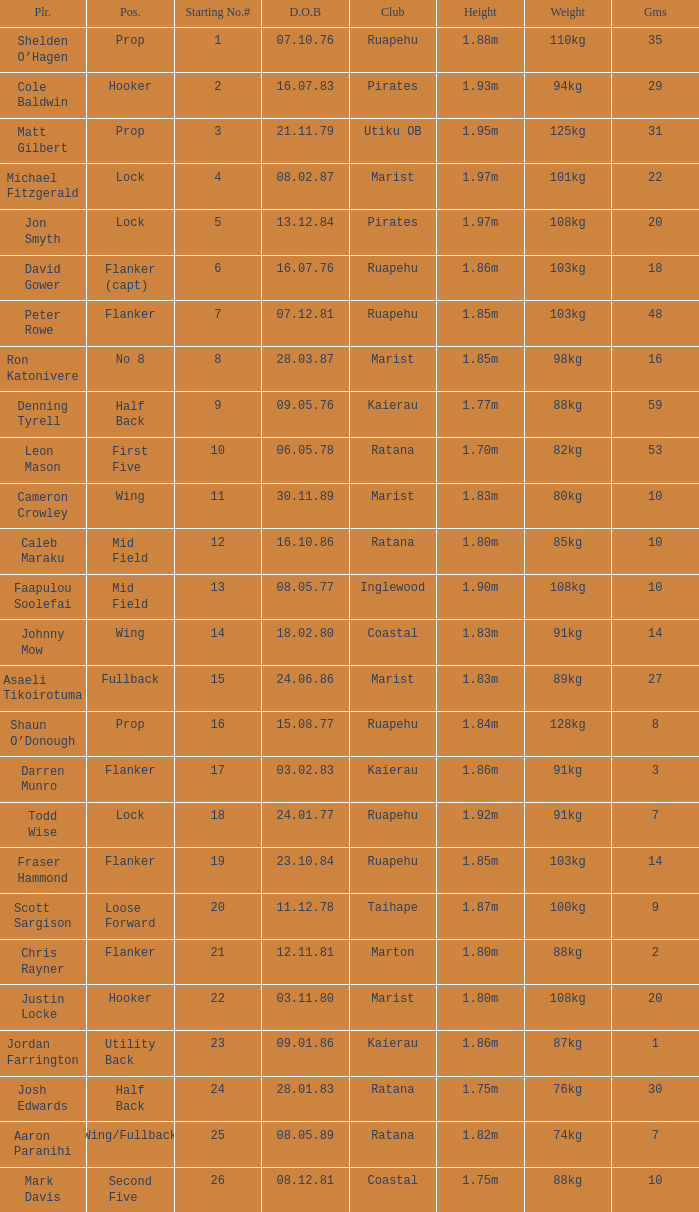What position does the player Todd Wise play in? Lock. 